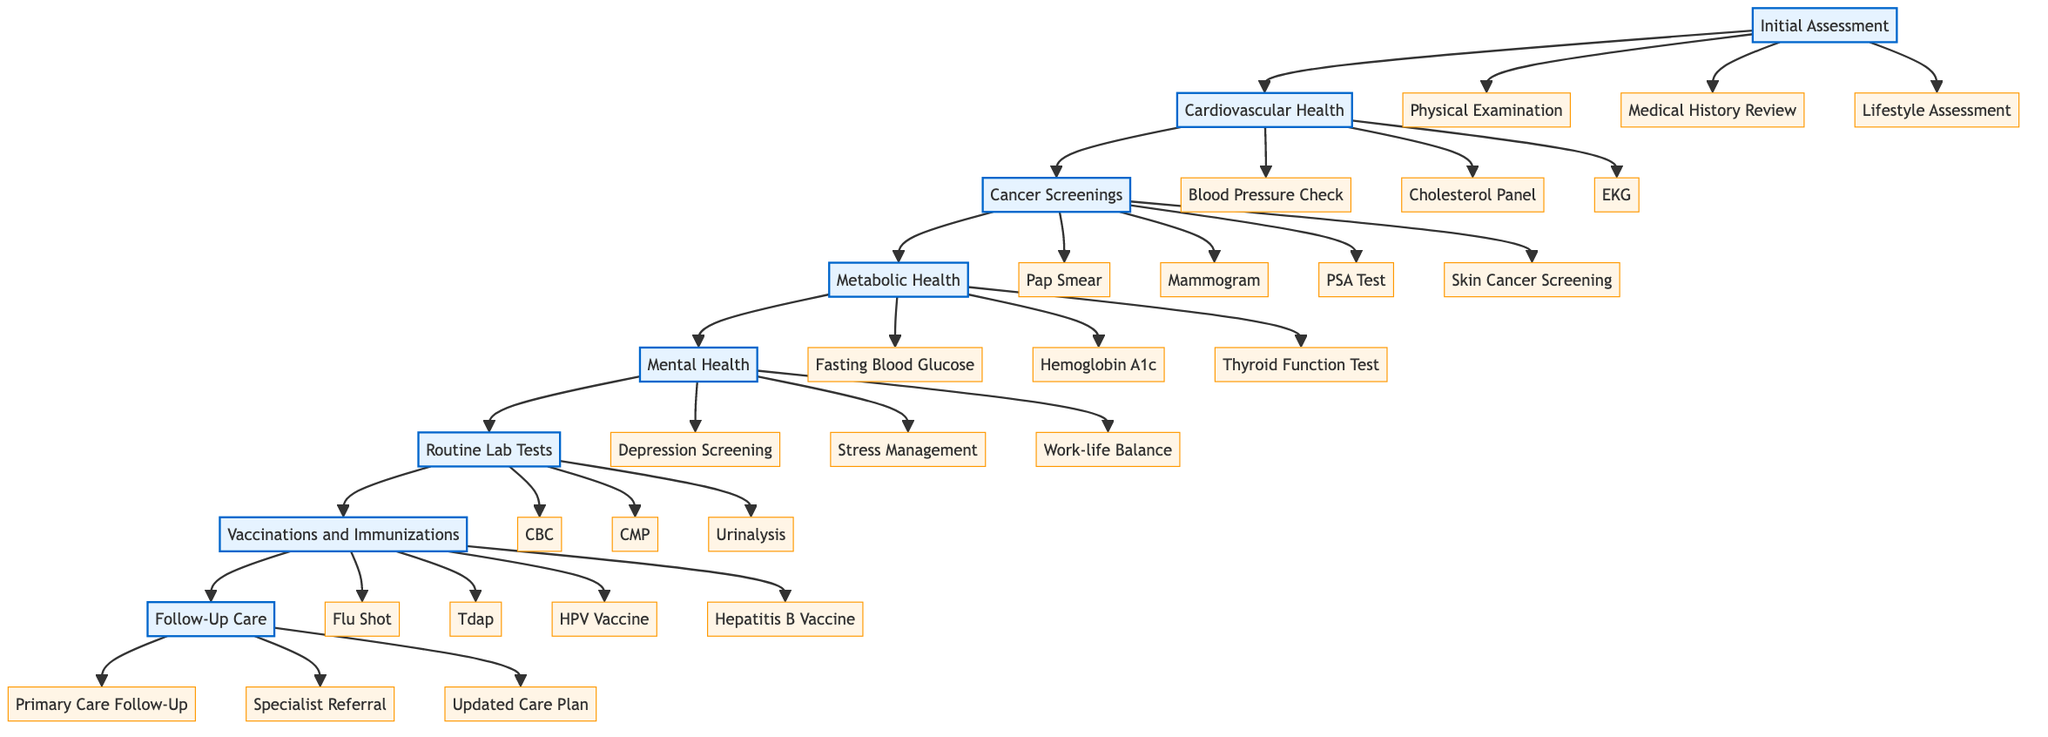What is the first step in the clinical pathway? The initial assessment is the starting point of the pathway and is represented as the first node in the diagram.
Answer: Initial Assessment How many steps are there in total in the clinical pathway? Counting each step represented in the diagram, there are a total of eight distinct steps listed.
Answer: 8 What are the entities listed under the 'Mental Health' step? By examining the 'Mental Health' node, the specific entities are identified, which include depression screening, stress management, and work-life balance evaluation.
Answer: Depression and Anxiety Screening, Stress Management Counseling, Work-life Balance Evaluation Which step follows 'Cancer Screenings'? By looking at the flow of the diagram, the node that directly follows 'Cancer Screenings' is 'Metabolic Health'.
Answer: Metabolic Health What three entities are part of 'Routine Lab Tests'? The diagram shows specific entities under 'Routine Lab Tests', which include Complete Blood Count, Comprehensive Metabolic Panel, and Urinalysis.
Answer: Complete Blood Count, Comprehensive Metabolic Panel, Urinalysis In which step is the 'Flu Shot' mentioned? The 'Flu Shot' appears as one of the entities listed under the 'Vaccinations and Immunizations' step in the diagram.
Answer: Vaccinations and Immunizations What is the last step in the clinical pathway? Observing the sequential flow in the diagram leads to the conclusion that the last step is 'Follow-Up Care'.
Answer: Follow-Up Care How many entities are associated with 'Cardiovascular Health'? The diagram specifies three entities under 'Cardiovascular Health', which are blood pressure check, cholesterol panel, and EKG.
Answer: 3 What action is taken after the 'Initial Assessment'? Following the 'Initial Assessment', the next action represented in the pathway is the 'Cardiovascular Health' step.
Answer: Cardiovascular Health 